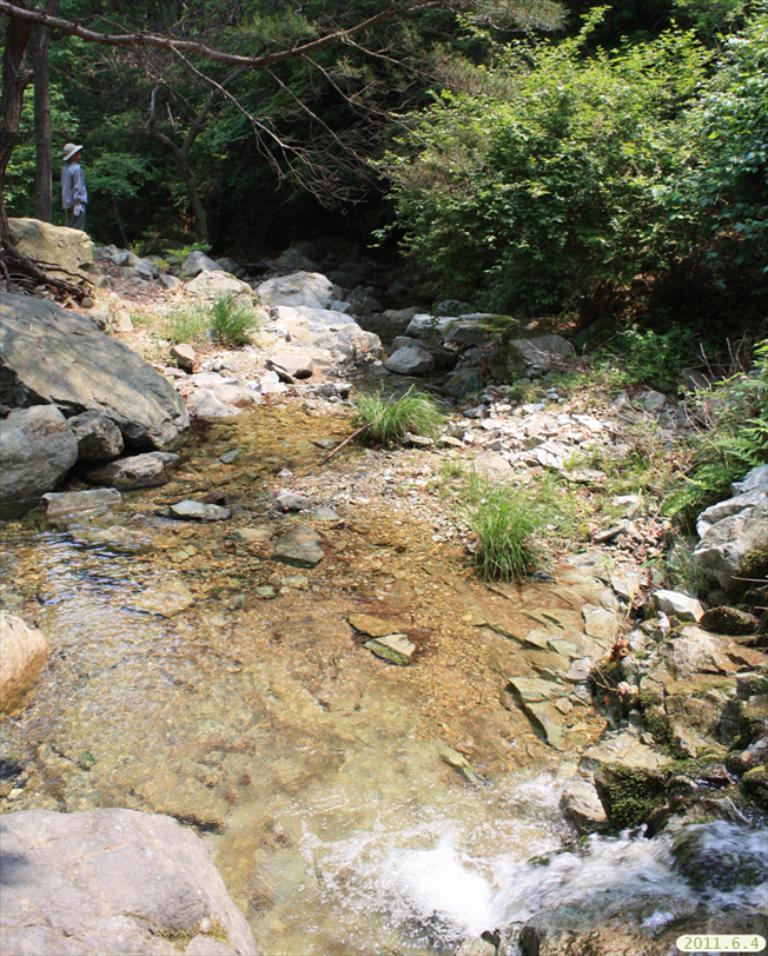How would you summarize this image in a sentence or two? In this picture we can see plants, stores, water and a person wore a hat and standing and in the background we can see trees. 